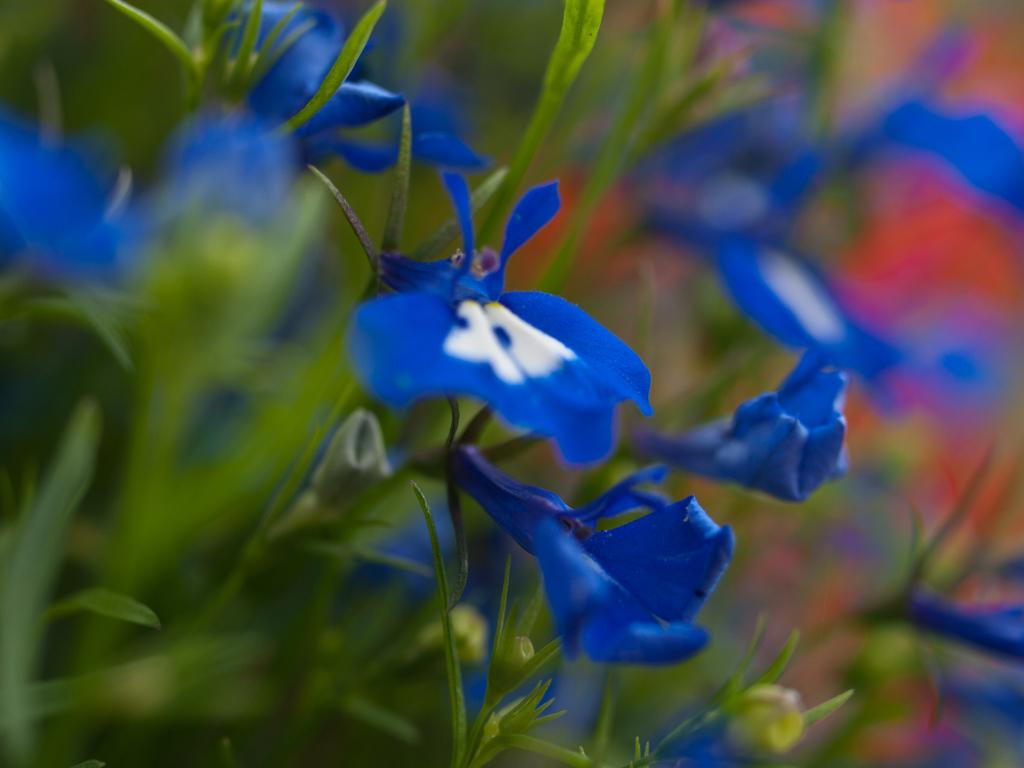What type of living organisms can be seen in the image? Plants can be seen in the image. What color are the flowers on the plants in the image? The flowers on the plants in the image are blue. What type of wool can be seen on the line in the image? There is no wool or line present in the image; it only features plants with blue flowers. 